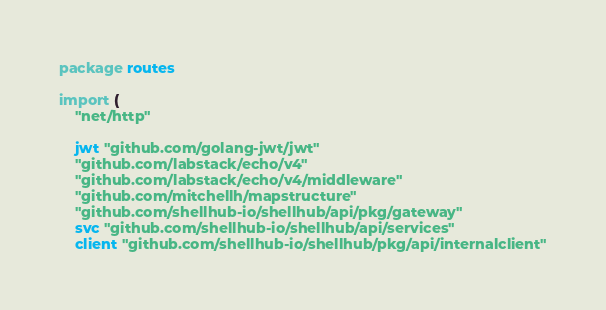Convert code to text. <code><loc_0><loc_0><loc_500><loc_500><_Go_>package routes

import (
	"net/http"

	jwt "github.com/golang-jwt/jwt"
	"github.com/labstack/echo/v4"
	"github.com/labstack/echo/v4/middleware"
	"github.com/mitchellh/mapstructure"
	"github.com/shellhub-io/shellhub/api/pkg/gateway"
	svc "github.com/shellhub-io/shellhub/api/services"
	client "github.com/shellhub-io/shellhub/pkg/api/internalclient"</code> 